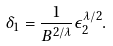<formula> <loc_0><loc_0><loc_500><loc_500>\delta _ { 1 } = \frac { 1 } { B ^ { 2 / \lambda } } \epsilon _ { 2 } ^ { \lambda / 2 } .</formula> 